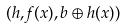<formula> <loc_0><loc_0><loc_500><loc_500>( h , f ( x ) , b \oplus h ( x ) )</formula> 